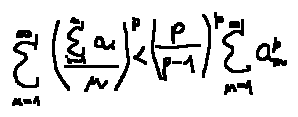Convert formula to latex. <formula><loc_0><loc_0><loc_500><loc_500>\sum \lim i t s _ { n = 1 } ^ { \infty } ( \frac { \sum \lim i t s _ { i = 1 } ^ { n } a _ { i } } { n } ) ^ { p } < ( \frac { p } { p - 1 } ) ^ { p } \sum \lim i t s _ { n = 1 } ^ { \infty } a _ { n } ^ { p }</formula> 